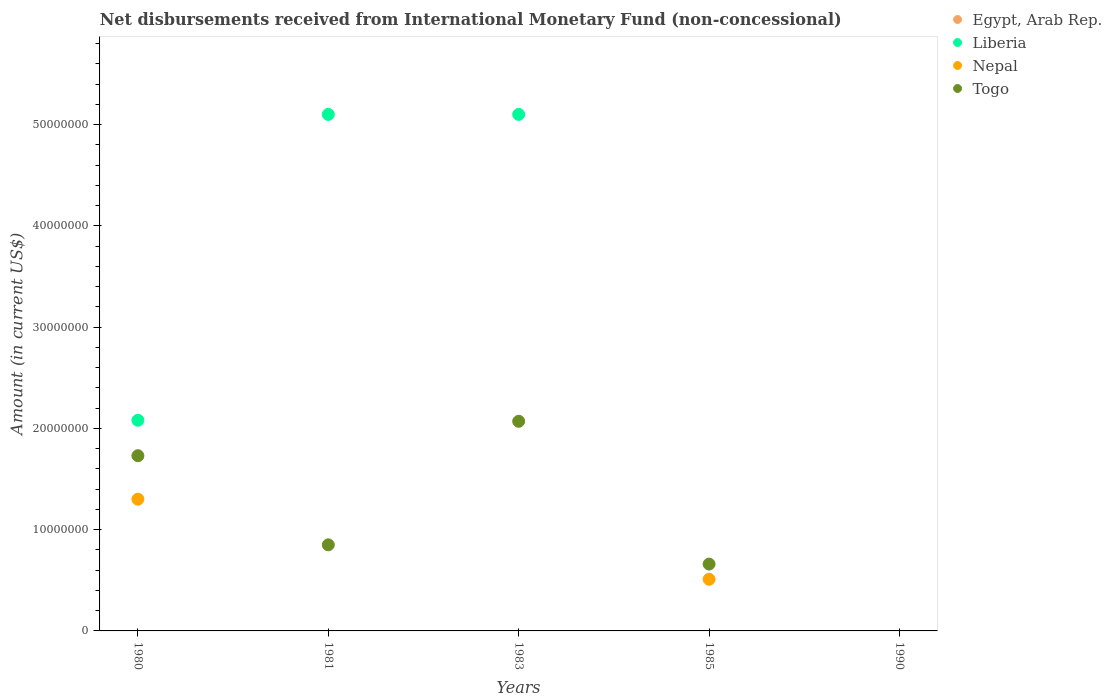Is the number of dotlines equal to the number of legend labels?
Offer a very short reply. No. Across all years, what is the maximum amount of disbursements received from International Monetary Fund in Nepal?
Provide a short and direct response. 1.30e+07. Across all years, what is the minimum amount of disbursements received from International Monetary Fund in Togo?
Give a very brief answer. 0. What is the total amount of disbursements received from International Monetary Fund in Nepal in the graph?
Make the answer very short. 1.81e+07. What is the difference between the amount of disbursements received from International Monetary Fund in Nepal in 1980 and that in 1985?
Give a very brief answer. 7.91e+06. What is the difference between the amount of disbursements received from International Monetary Fund in Egypt, Arab Rep. in 1981 and the amount of disbursements received from International Monetary Fund in Togo in 1980?
Your answer should be very brief. -1.73e+07. What is the average amount of disbursements received from International Monetary Fund in Liberia per year?
Your answer should be compact. 2.46e+07. In the year 1980, what is the difference between the amount of disbursements received from International Monetary Fund in Togo and amount of disbursements received from International Monetary Fund in Nepal?
Offer a very short reply. 4.29e+06. What is the ratio of the amount of disbursements received from International Monetary Fund in Togo in 1981 to that in 1983?
Provide a short and direct response. 0.41. What is the difference between the highest and the lowest amount of disbursements received from International Monetary Fund in Togo?
Your answer should be compact. 2.07e+07. Is the sum of the amount of disbursements received from International Monetary Fund in Togo in 1981 and 1985 greater than the maximum amount of disbursements received from International Monetary Fund in Liberia across all years?
Offer a terse response. No. Is it the case that in every year, the sum of the amount of disbursements received from International Monetary Fund in Egypt, Arab Rep. and amount of disbursements received from International Monetary Fund in Nepal  is greater than the sum of amount of disbursements received from International Monetary Fund in Liberia and amount of disbursements received from International Monetary Fund in Togo?
Offer a very short reply. No. Is it the case that in every year, the sum of the amount of disbursements received from International Monetary Fund in Liberia and amount of disbursements received from International Monetary Fund in Togo  is greater than the amount of disbursements received from International Monetary Fund in Egypt, Arab Rep.?
Keep it short and to the point. No. Is the amount of disbursements received from International Monetary Fund in Egypt, Arab Rep. strictly less than the amount of disbursements received from International Monetary Fund in Nepal over the years?
Offer a very short reply. No. How many years are there in the graph?
Your answer should be very brief. 5. What is the difference between two consecutive major ticks on the Y-axis?
Offer a very short reply. 1.00e+07. Does the graph contain any zero values?
Give a very brief answer. Yes. Does the graph contain grids?
Make the answer very short. No. Where does the legend appear in the graph?
Ensure brevity in your answer.  Top right. How many legend labels are there?
Keep it short and to the point. 4. How are the legend labels stacked?
Your answer should be very brief. Vertical. What is the title of the graph?
Your response must be concise. Net disbursements received from International Monetary Fund (non-concessional). What is the Amount (in current US$) in Egypt, Arab Rep. in 1980?
Ensure brevity in your answer.  0. What is the Amount (in current US$) in Liberia in 1980?
Offer a terse response. 2.08e+07. What is the Amount (in current US$) in Nepal in 1980?
Your answer should be very brief. 1.30e+07. What is the Amount (in current US$) in Togo in 1980?
Your answer should be compact. 1.73e+07. What is the Amount (in current US$) in Egypt, Arab Rep. in 1981?
Ensure brevity in your answer.  0. What is the Amount (in current US$) of Liberia in 1981?
Your response must be concise. 5.10e+07. What is the Amount (in current US$) in Togo in 1981?
Offer a terse response. 8.50e+06. What is the Amount (in current US$) of Liberia in 1983?
Your response must be concise. 5.10e+07. What is the Amount (in current US$) of Nepal in 1983?
Your answer should be compact. 0. What is the Amount (in current US$) of Togo in 1983?
Provide a succinct answer. 2.07e+07. What is the Amount (in current US$) of Nepal in 1985?
Offer a very short reply. 5.10e+06. What is the Amount (in current US$) in Togo in 1985?
Offer a terse response. 6.60e+06. What is the Amount (in current US$) of Egypt, Arab Rep. in 1990?
Offer a terse response. 0. What is the Amount (in current US$) of Liberia in 1990?
Ensure brevity in your answer.  0. What is the Amount (in current US$) in Nepal in 1990?
Your answer should be very brief. 0. Across all years, what is the maximum Amount (in current US$) of Liberia?
Ensure brevity in your answer.  5.10e+07. Across all years, what is the maximum Amount (in current US$) in Nepal?
Ensure brevity in your answer.  1.30e+07. Across all years, what is the maximum Amount (in current US$) in Togo?
Keep it short and to the point. 2.07e+07. What is the total Amount (in current US$) in Liberia in the graph?
Provide a succinct answer. 1.23e+08. What is the total Amount (in current US$) of Nepal in the graph?
Offer a terse response. 1.81e+07. What is the total Amount (in current US$) of Togo in the graph?
Keep it short and to the point. 5.31e+07. What is the difference between the Amount (in current US$) in Liberia in 1980 and that in 1981?
Offer a terse response. -3.02e+07. What is the difference between the Amount (in current US$) of Togo in 1980 and that in 1981?
Keep it short and to the point. 8.80e+06. What is the difference between the Amount (in current US$) of Liberia in 1980 and that in 1983?
Offer a terse response. -3.02e+07. What is the difference between the Amount (in current US$) of Togo in 1980 and that in 1983?
Provide a short and direct response. -3.40e+06. What is the difference between the Amount (in current US$) of Nepal in 1980 and that in 1985?
Give a very brief answer. 7.91e+06. What is the difference between the Amount (in current US$) of Togo in 1980 and that in 1985?
Provide a short and direct response. 1.07e+07. What is the difference between the Amount (in current US$) in Togo in 1981 and that in 1983?
Your answer should be very brief. -1.22e+07. What is the difference between the Amount (in current US$) in Togo in 1981 and that in 1985?
Make the answer very short. 1.90e+06. What is the difference between the Amount (in current US$) in Togo in 1983 and that in 1985?
Provide a short and direct response. 1.41e+07. What is the difference between the Amount (in current US$) in Liberia in 1980 and the Amount (in current US$) in Togo in 1981?
Offer a terse response. 1.23e+07. What is the difference between the Amount (in current US$) in Nepal in 1980 and the Amount (in current US$) in Togo in 1981?
Offer a very short reply. 4.51e+06. What is the difference between the Amount (in current US$) in Liberia in 1980 and the Amount (in current US$) in Togo in 1983?
Your answer should be compact. 1.00e+05. What is the difference between the Amount (in current US$) of Nepal in 1980 and the Amount (in current US$) of Togo in 1983?
Your answer should be compact. -7.69e+06. What is the difference between the Amount (in current US$) of Liberia in 1980 and the Amount (in current US$) of Nepal in 1985?
Offer a very short reply. 1.57e+07. What is the difference between the Amount (in current US$) of Liberia in 1980 and the Amount (in current US$) of Togo in 1985?
Provide a short and direct response. 1.42e+07. What is the difference between the Amount (in current US$) of Nepal in 1980 and the Amount (in current US$) of Togo in 1985?
Your response must be concise. 6.41e+06. What is the difference between the Amount (in current US$) of Liberia in 1981 and the Amount (in current US$) of Togo in 1983?
Ensure brevity in your answer.  3.03e+07. What is the difference between the Amount (in current US$) of Liberia in 1981 and the Amount (in current US$) of Nepal in 1985?
Ensure brevity in your answer.  4.59e+07. What is the difference between the Amount (in current US$) of Liberia in 1981 and the Amount (in current US$) of Togo in 1985?
Provide a short and direct response. 4.44e+07. What is the difference between the Amount (in current US$) of Liberia in 1983 and the Amount (in current US$) of Nepal in 1985?
Offer a terse response. 4.59e+07. What is the difference between the Amount (in current US$) of Liberia in 1983 and the Amount (in current US$) of Togo in 1985?
Provide a short and direct response. 4.44e+07. What is the average Amount (in current US$) in Liberia per year?
Your response must be concise. 2.46e+07. What is the average Amount (in current US$) in Nepal per year?
Your answer should be very brief. 3.62e+06. What is the average Amount (in current US$) of Togo per year?
Give a very brief answer. 1.06e+07. In the year 1980, what is the difference between the Amount (in current US$) in Liberia and Amount (in current US$) in Nepal?
Ensure brevity in your answer.  7.79e+06. In the year 1980, what is the difference between the Amount (in current US$) in Liberia and Amount (in current US$) in Togo?
Keep it short and to the point. 3.50e+06. In the year 1980, what is the difference between the Amount (in current US$) of Nepal and Amount (in current US$) of Togo?
Provide a short and direct response. -4.29e+06. In the year 1981, what is the difference between the Amount (in current US$) in Liberia and Amount (in current US$) in Togo?
Your response must be concise. 4.25e+07. In the year 1983, what is the difference between the Amount (in current US$) of Liberia and Amount (in current US$) of Togo?
Provide a succinct answer. 3.03e+07. In the year 1985, what is the difference between the Amount (in current US$) of Nepal and Amount (in current US$) of Togo?
Offer a very short reply. -1.50e+06. What is the ratio of the Amount (in current US$) of Liberia in 1980 to that in 1981?
Make the answer very short. 0.41. What is the ratio of the Amount (in current US$) in Togo in 1980 to that in 1981?
Give a very brief answer. 2.04. What is the ratio of the Amount (in current US$) of Liberia in 1980 to that in 1983?
Your response must be concise. 0.41. What is the ratio of the Amount (in current US$) of Togo in 1980 to that in 1983?
Offer a very short reply. 0.84. What is the ratio of the Amount (in current US$) of Nepal in 1980 to that in 1985?
Your answer should be compact. 2.55. What is the ratio of the Amount (in current US$) in Togo in 1980 to that in 1985?
Offer a very short reply. 2.62. What is the ratio of the Amount (in current US$) of Liberia in 1981 to that in 1983?
Make the answer very short. 1. What is the ratio of the Amount (in current US$) in Togo in 1981 to that in 1983?
Keep it short and to the point. 0.41. What is the ratio of the Amount (in current US$) of Togo in 1981 to that in 1985?
Your answer should be very brief. 1.29. What is the ratio of the Amount (in current US$) of Togo in 1983 to that in 1985?
Provide a succinct answer. 3.14. What is the difference between the highest and the second highest Amount (in current US$) in Togo?
Offer a very short reply. 3.40e+06. What is the difference between the highest and the lowest Amount (in current US$) of Liberia?
Your response must be concise. 5.10e+07. What is the difference between the highest and the lowest Amount (in current US$) in Nepal?
Your answer should be very brief. 1.30e+07. What is the difference between the highest and the lowest Amount (in current US$) of Togo?
Offer a terse response. 2.07e+07. 